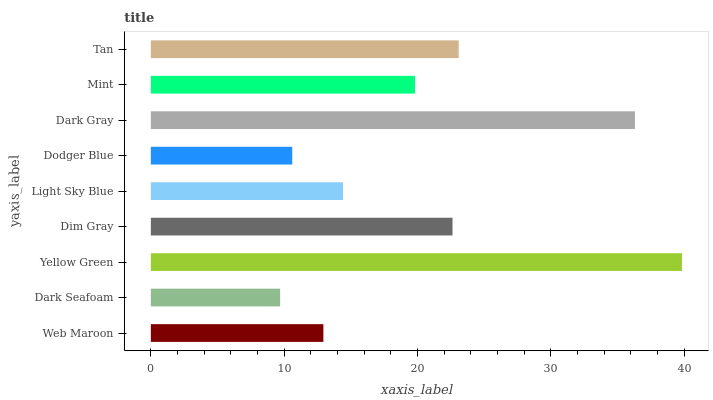Is Dark Seafoam the minimum?
Answer yes or no. Yes. Is Yellow Green the maximum?
Answer yes or no. Yes. Is Yellow Green the minimum?
Answer yes or no. No. Is Dark Seafoam the maximum?
Answer yes or no. No. Is Yellow Green greater than Dark Seafoam?
Answer yes or no. Yes. Is Dark Seafoam less than Yellow Green?
Answer yes or no. Yes. Is Dark Seafoam greater than Yellow Green?
Answer yes or no. No. Is Yellow Green less than Dark Seafoam?
Answer yes or no. No. Is Mint the high median?
Answer yes or no. Yes. Is Mint the low median?
Answer yes or no. Yes. Is Dim Gray the high median?
Answer yes or no. No. Is Dodger Blue the low median?
Answer yes or no. No. 